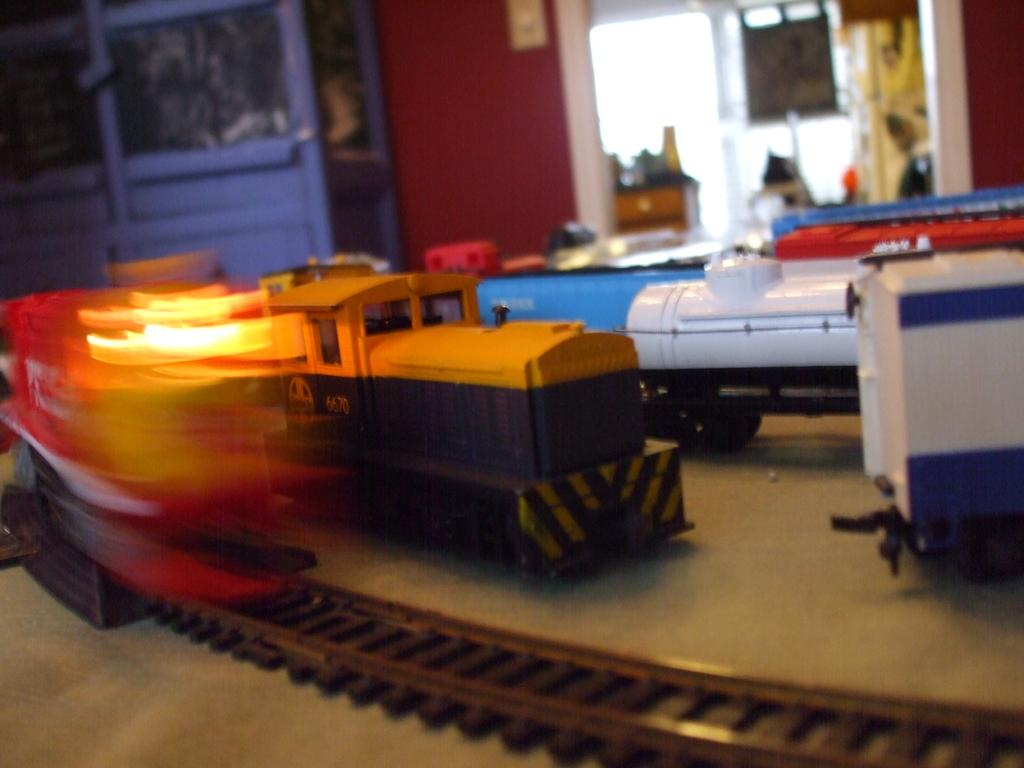What is the main subject in the center of the image? There is a toy train in the center of the image. What is the toy train placed on? The toy train is placed on a railway track. Where is the railway track located? The railway track is placed on a table. What can be seen in the background of the image? There are cupboards, a door, a window, a curtain, and a wall in the background of the image. What type of spark can be seen coming from the toy train in the image? There is no spark visible in the image; the toy train is stationary on the railway track. 